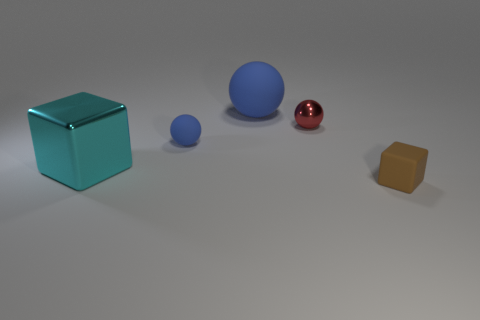Are the small thing in front of the large cyan shiny thing and the red sphere made of the same material?
Provide a succinct answer. No. Is the number of red metallic balls right of the red sphere less than the number of red metal balls?
Your answer should be very brief. Yes. There is a object behind the red object; what is its shape?
Keep it short and to the point. Sphere. There is a thing that is the same size as the shiny cube; what shape is it?
Offer a very short reply. Sphere. Are there any tiny blue things of the same shape as the red metal object?
Provide a succinct answer. Yes. There is a shiny object that is left of the big matte sphere; is it the same shape as the blue rubber object that is to the right of the tiny blue rubber object?
Offer a terse response. No. What material is the other thing that is the same size as the cyan object?
Ensure brevity in your answer.  Rubber. How many other objects are the same material as the red thing?
Give a very brief answer. 1. There is a metallic object left of the matte object that is behind the small rubber sphere; what shape is it?
Your response must be concise. Cube. What number of objects are tiny red metal things or balls behind the tiny shiny ball?
Your response must be concise. 2. 